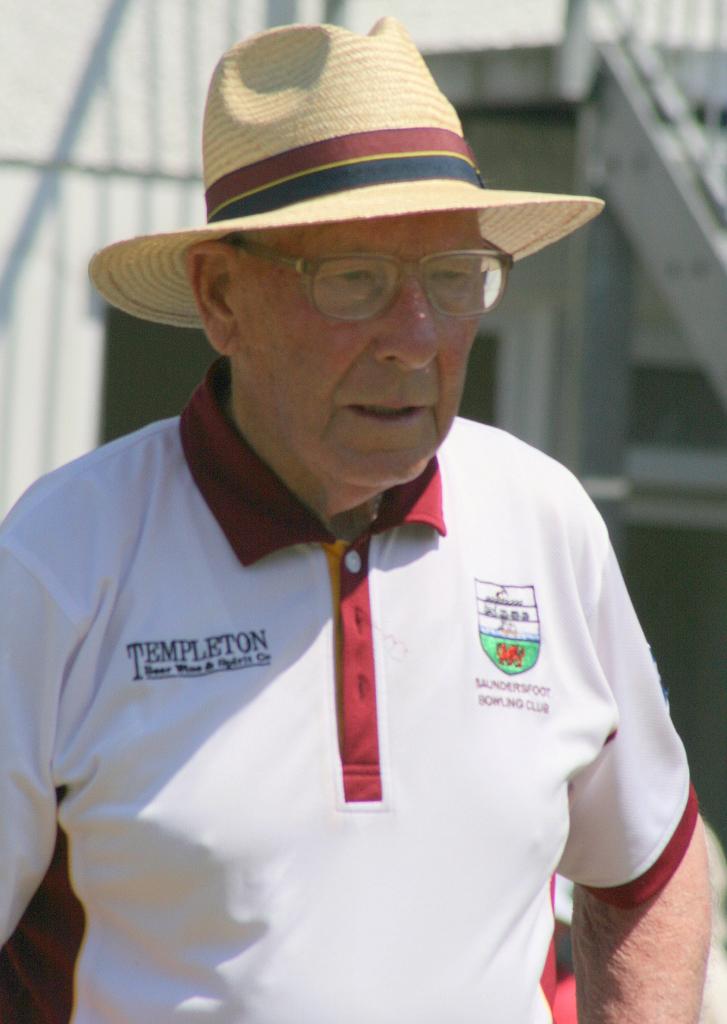What company is the shirt from?
Your response must be concise. Templeton. 